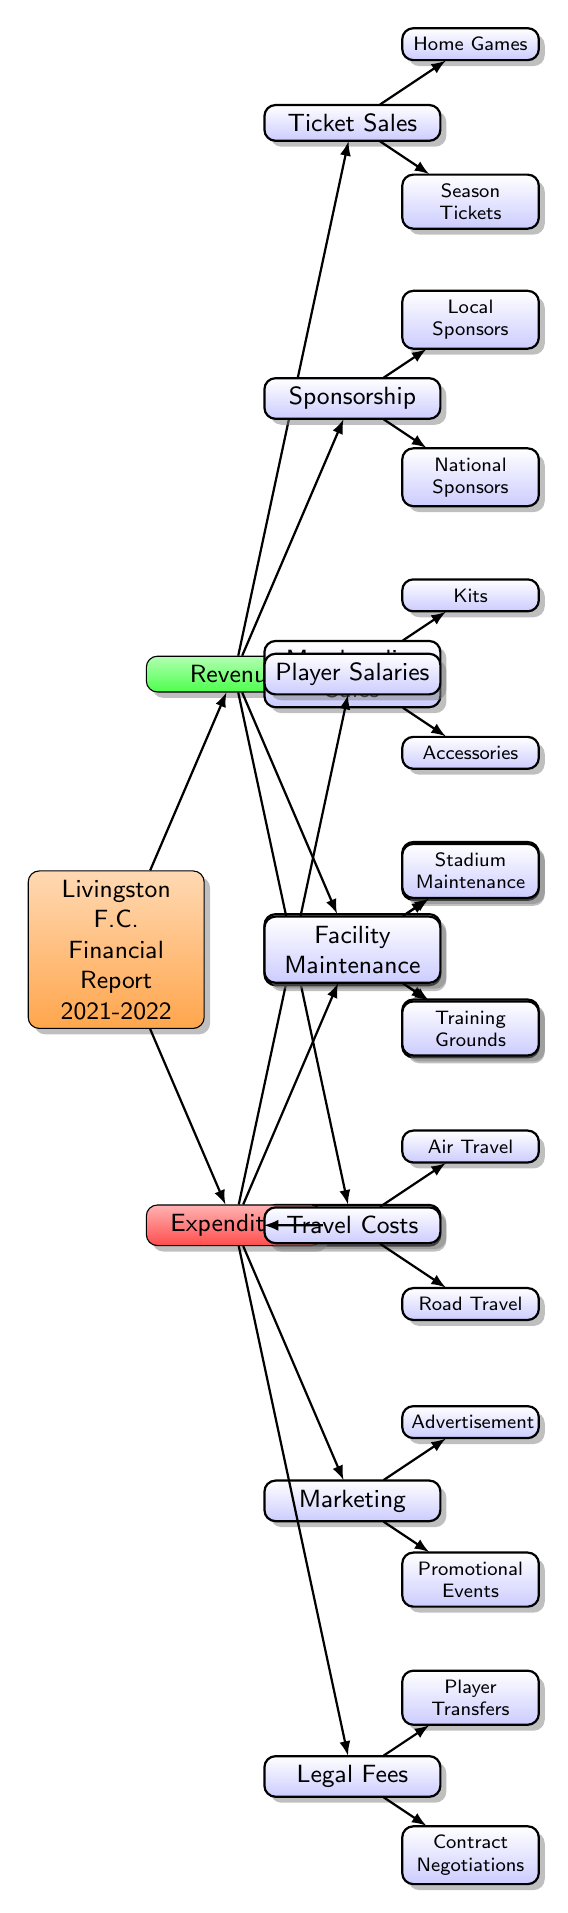What are the two main categories in the financial report? The diagram reveals two primary categories: Revenue and Expenditure, indicated as the main branches stemming from the root node titled "Financial Report."
Answer: Revenue and Expenditure How many subcategories are under Revenue? By examining the Revenue category, we see that it has four subcategories: Ticket Sales, Sponsorship, Merchandise Sales, and Broadcast Rights. Therefore, the total count is four.
Answer: Four What is one source of income listed under Sponsorship? The Sponsorship category contains two sources of income: Local Sponsors and National Sponsors. Choosing either gives us one valid answer.
Answer: Local Sponsors Which expenditure category includes player transfers? The Legal Fees category includes subcategories related to player transfers as well as contract negotiations. The direct link from Legal Fees to Player Transfers designates this as the associated expenditure category.
Answer: Legal Fees What is the relationship between Merchandise Sales and Kits? Merchandise Sales is the parent node, and Kits is a leaf node directly stemming from Merchandise Sales. Thus, the relationship is that Kits is a type of Merchandise Sales.
Answer: Kits is a type of Merchandise Sales Which type of travel costs is specifically listed in the diagram? Under the Travel Costs category, there are two specific types mentioned: Air Travel and Road Travel. Each is a distinct subcategory under the broader Travel Costs.
Answer: Air Travel and Road Travel Which category has the highest number of subcategories? Upon inspection, the Revenue category has more subcategories (five) compared to the Expenditure category, which contains four. Therefore, Revenue stands out with the highest count.
Answer: Revenue What are the two types of legal fees listed? Under Legal Fees, there are two specific types mentioned: Player Transfers and Contract Negotiations. Both are directly associated with the Legal Fees category.
Answer: Player Transfers and Contract Negotiations How many revenue streams are related to broadcast rights? The Broadcast Rights category shows two distinct revenue streams, which are Scottish Premiership and Cup Competitions. Therefore, the total count of revenue streams in this category is two.
Answer: Two 